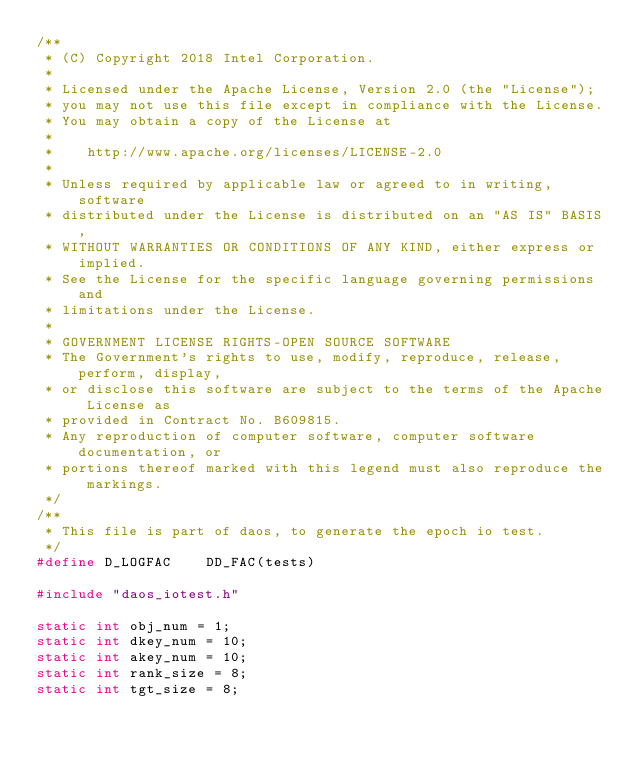Convert code to text. <code><loc_0><loc_0><loc_500><loc_500><_C_>/**
 * (C) Copyright 2018 Intel Corporation.
 *
 * Licensed under the Apache License, Version 2.0 (the "License");
 * you may not use this file except in compliance with the License.
 * You may obtain a copy of the License at
 *
 *    http://www.apache.org/licenses/LICENSE-2.0
 *
 * Unless required by applicable law or agreed to in writing, software
 * distributed under the License is distributed on an "AS IS" BASIS,
 * WITHOUT WARRANTIES OR CONDITIONS OF ANY KIND, either express or implied.
 * See the License for the specific language governing permissions and
 * limitations under the License.
 *
 * GOVERNMENT LICENSE RIGHTS-OPEN SOURCE SOFTWARE
 * The Government's rights to use, modify, reproduce, release, perform, display,
 * or disclose this software are subject to the terms of the Apache License as
 * provided in Contract No. B609815.
 * Any reproduction of computer software, computer software documentation, or
 * portions thereof marked with this legend must also reproduce the markings.
 */
/**
 * This file is part of daos, to generate the epoch io test.
 */
#define D_LOGFAC	DD_FAC(tests)

#include "daos_iotest.h"

static int obj_num = 1;
static int dkey_num = 10;
static int akey_num = 10;
static int rank_size = 8;
static int tgt_size = 8;</code> 